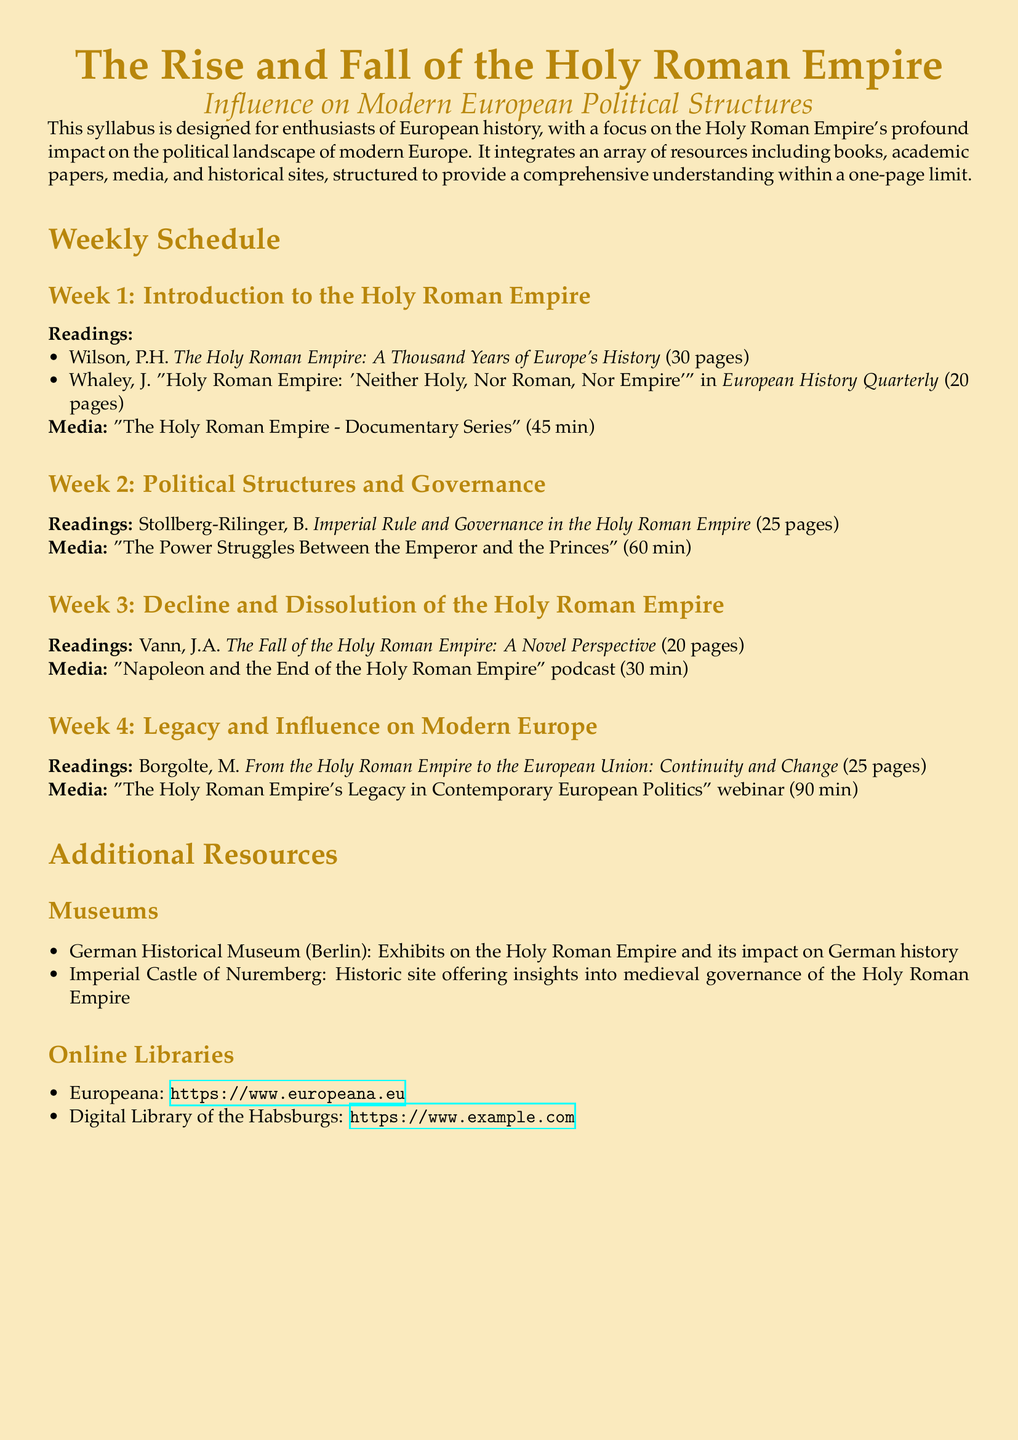What is the title of the syllabus? The title is stated at the top of the document, summarizing the main focus of the syllabus.
Answer: The Rise and Fall of the Holy Roman Empire How many weeks are outlined in the syllabus? The syllabus details a weekly schedule with specific topics assigned to each week.
Answer: 4 Which author wrote about the governance in the Holy Roman Empire? The specific author and title that address governance is listed in the readings for Week 2.
Answer: Stollberg-Rilinger What type of media is included in Week 4? The syllabus specifies the type of media used for each week, particularly for Week 4, which deals with legacy.
Answer: Webinar What is the total duration of the media in Week 2? The document provides the length of the media specified for each week, focusing on Week 2.
Answer: 60 min Which museum is located in Berlin? The document mentions specific museums related to the Holy Roman Empire, including their locations.
Answer: German Historical Museum What is the page count for the readings assigned in Week 1? The syllabus lists specific page numbers for the readings for each week, particularly for Week 1.
Answer: 30 pages Which subject does Week 3 focus on? The syllabus outlines themes for each week, explicitly stating the focus of Week 3.
Answer: Decline and Dissolution What is the focus of the syllabus overall? The introductory sentence summarizes the main theme of the syllabus and its educational aim.
Answer: Influence on Modern European Political Structures 